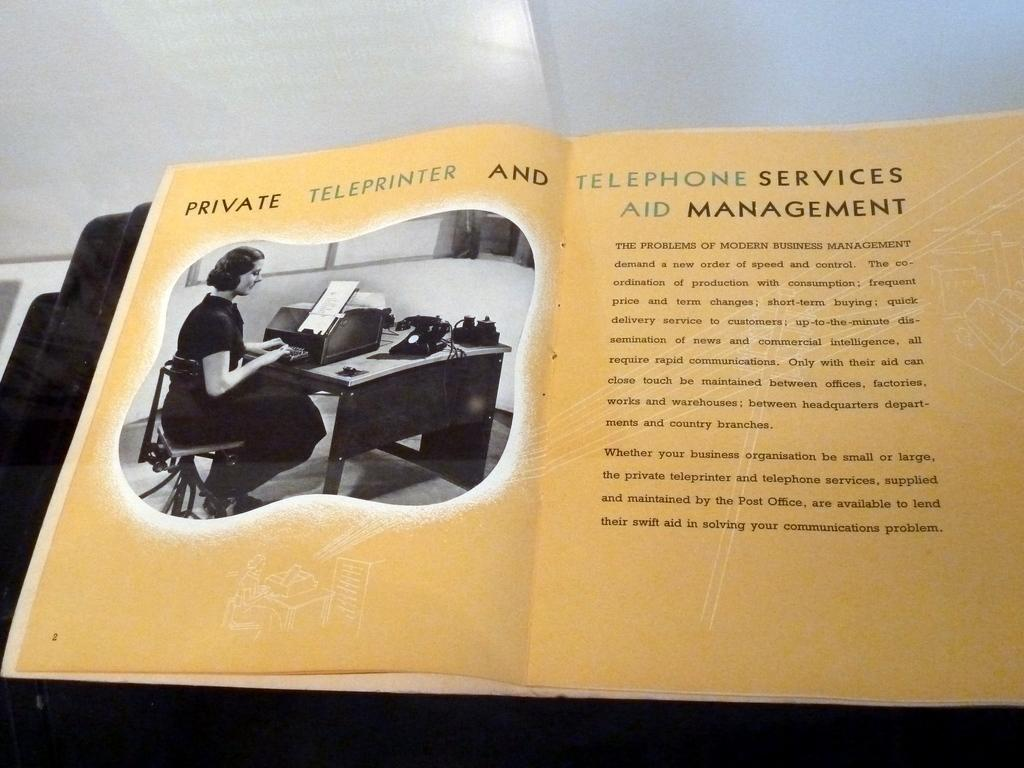Provide a one-sentence caption for the provided image. The books shown is opened to page 2. 